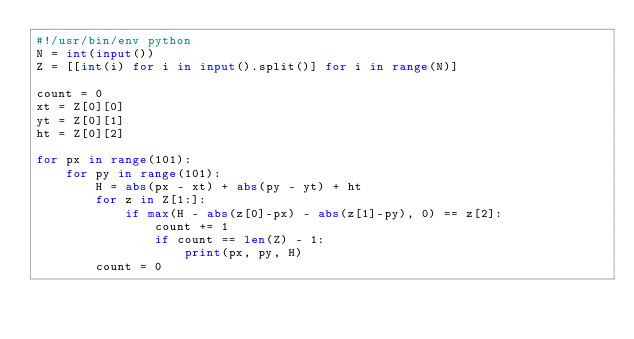<code> <loc_0><loc_0><loc_500><loc_500><_Python_>#!/usr/bin/env python
N = int(input())
Z = [[int(i) for i in input().split()] for i in range(N)]

count = 0
xt = Z[0][0]
yt = Z[0][1]
ht = Z[0][2]

for px in range(101):
    for py in range(101):
        H = abs(px - xt) + abs(py - yt) + ht
        for z in Z[1:]:
            if max(H - abs(z[0]-px) - abs(z[1]-py), 0) == z[2]:
                count += 1
                if count == len(Z) - 1:
                    print(px, py, H)
        count = 0</code> 